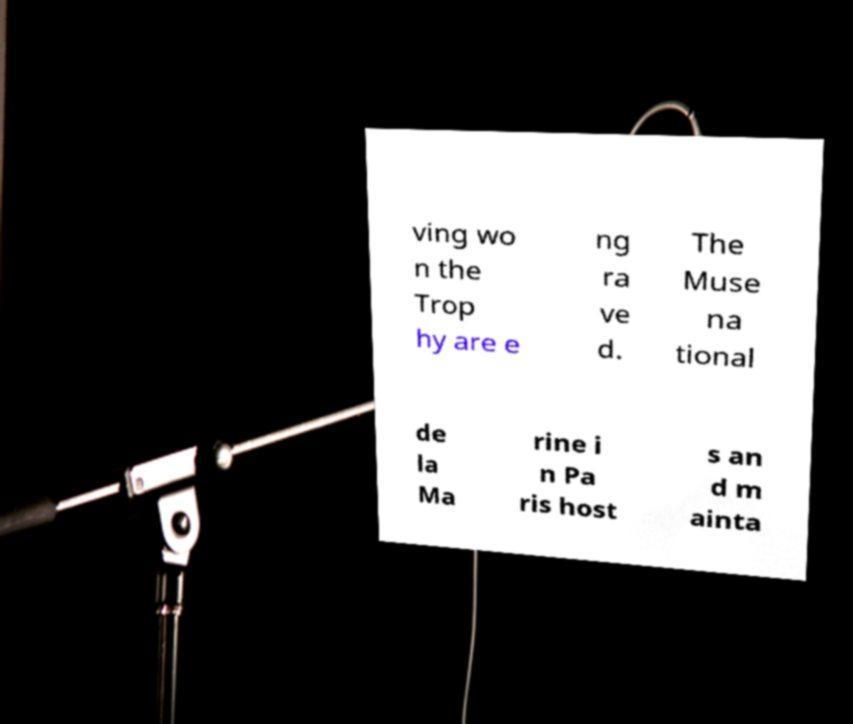Can you accurately transcribe the text from the provided image for me? ving wo n the Trop hy are e ng ra ve d. The Muse na tional de la Ma rine i n Pa ris host s an d m ainta 